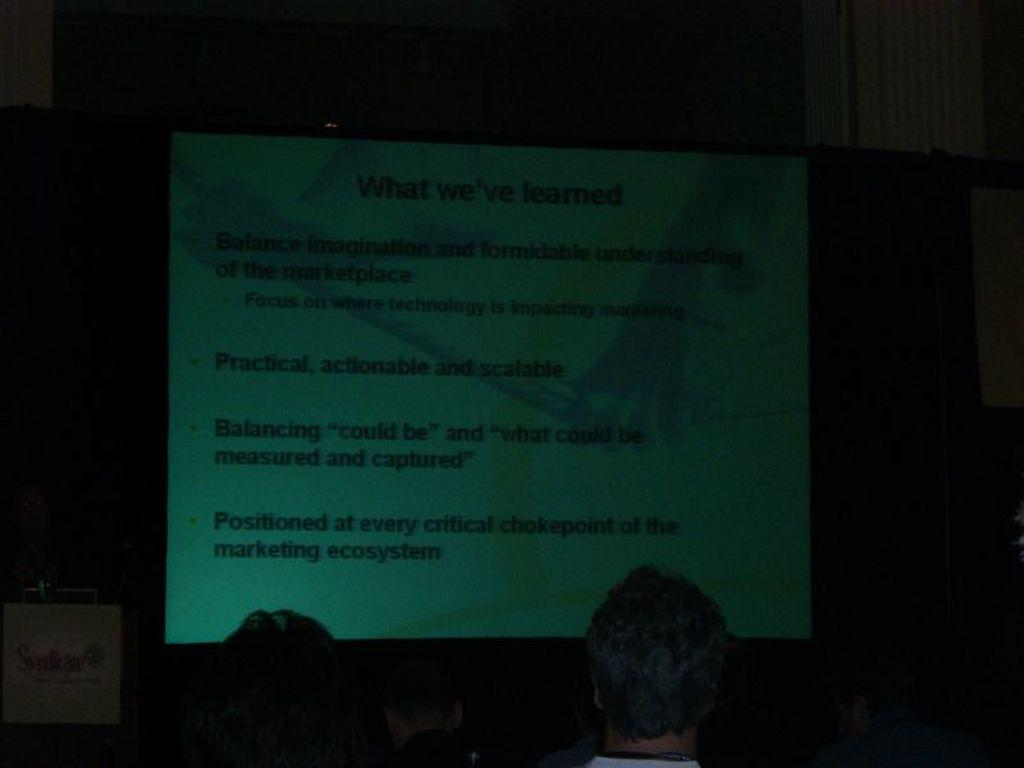What is the main object in the center of the image? There is a projector screen in the center of the image. Who or what is located at the bottom of the image? There are two persons at the bottom of the image. What can be seen in the background of the image? There is a wall in the background of the image. What type of fruit is being sliced by the knife in the image? There is no fruit or knife present in the image. 